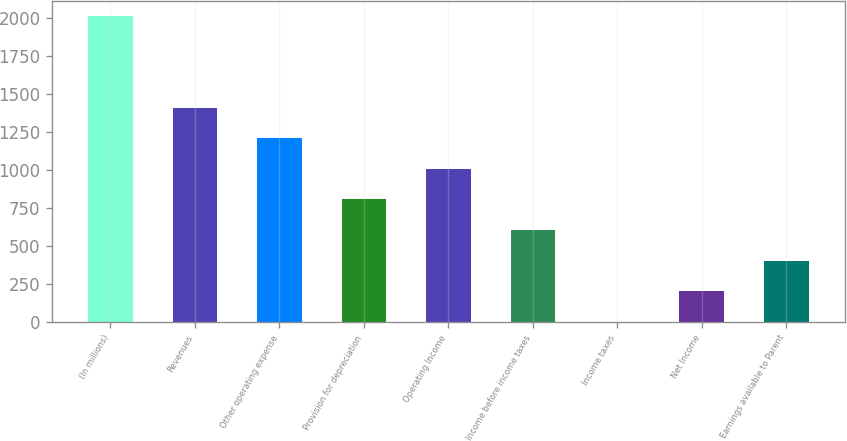<chart> <loc_0><loc_0><loc_500><loc_500><bar_chart><fcel>(In millions)<fcel>Revenues<fcel>Other operating expense<fcel>Provision for depreciation<fcel>Operating Income<fcel>Income before income taxes<fcel>Income taxes<fcel>Net Income<fcel>Earnings available to Parent<nl><fcel>2011<fcel>1408.21<fcel>1207.28<fcel>805.42<fcel>1006.35<fcel>604.49<fcel>1.7<fcel>202.63<fcel>403.56<nl></chart> 